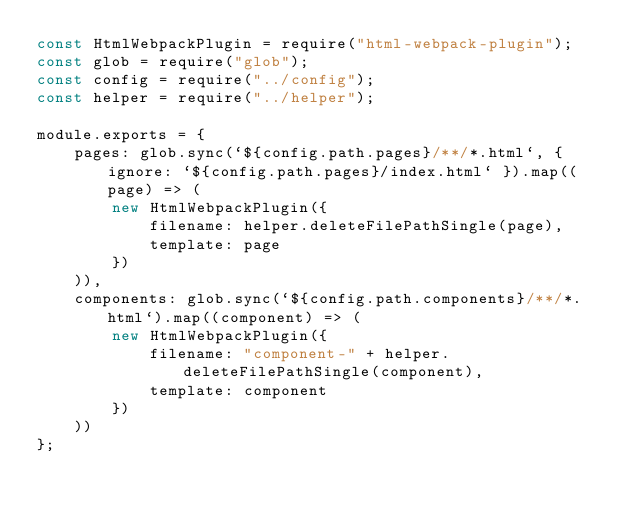<code> <loc_0><loc_0><loc_500><loc_500><_JavaScript_>const HtmlWebpackPlugin = require("html-webpack-plugin");
const glob = require("glob");
const config = require("../config");
const helper = require("../helper");

module.exports = {
    pages: glob.sync(`${config.path.pages}/**/*.html`, { ignore: `${config.path.pages}/index.html` }).map((page) => (
        new HtmlWebpackPlugin({
            filename: helper.deleteFilePathSingle(page),
            template: page
        })
    )),
    components: glob.sync(`${config.path.components}/**/*.html`).map((component) => (
        new HtmlWebpackPlugin({
            filename: "component-" + helper.deleteFilePathSingle(component),
            template: component
        })
    ))
};</code> 